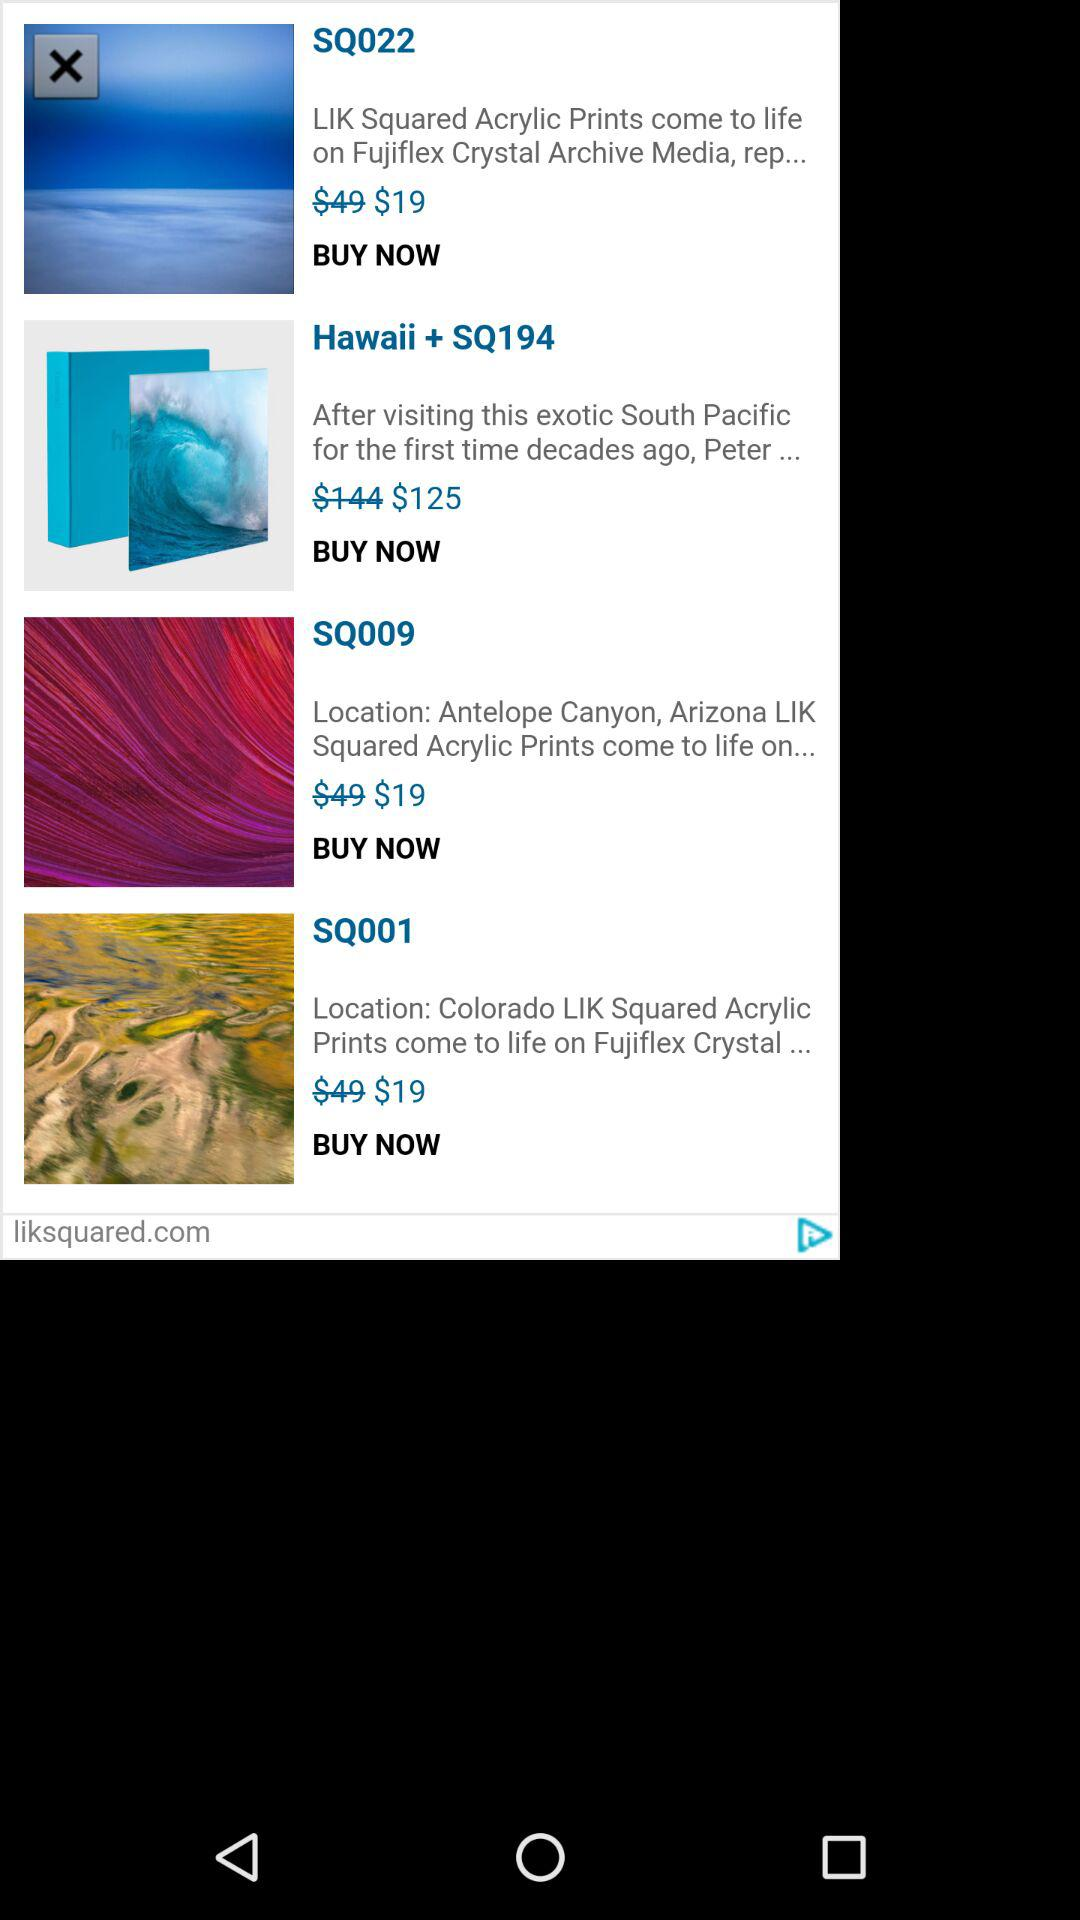What is the price of the "Hawaii + SQ194"? The price of the "Hawaii + SQ194" is $125. 